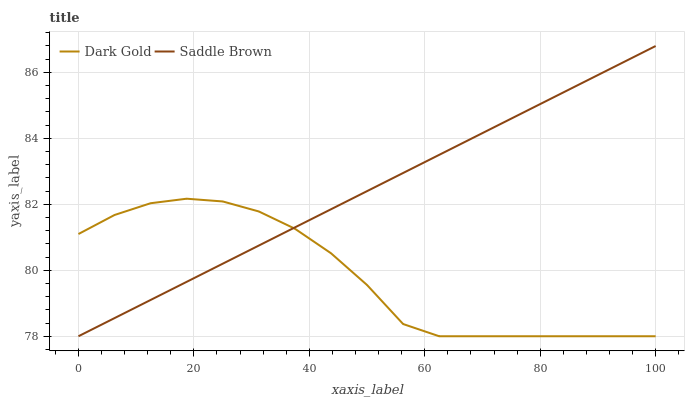Does Dark Gold have the minimum area under the curve?
Answer yes or no. Yes. Does Saddle Brown have the maximum area under the curve?
Answer yes or no. Yes. Does Dark Gold have the maximum area under the curve?
Answer yes or no. No. Is Saddle Brown the smoothest?
Answer yes or no. Yes. Is Dark Gold the roughest?
Answer yes or no. Yes. Is Dark Gold the smoothest?
Answer yes or no. No. Does Saddle Brown have the lowest value?
Answer yes or no. Yes. Does Saddle Brown have the highest value?
Answer yes or no. Yes. Does Dark Gold have the highest value?
Answer yes or no. No. Does Saddle Brown intersect Dark Gold?
Answer yes or no. Yes. Is Saddle Brown less than Dark Gold?
Answer yes or no. No. Is Saddle Brown greater than Dark Gold?
Answer yes or no. No. 